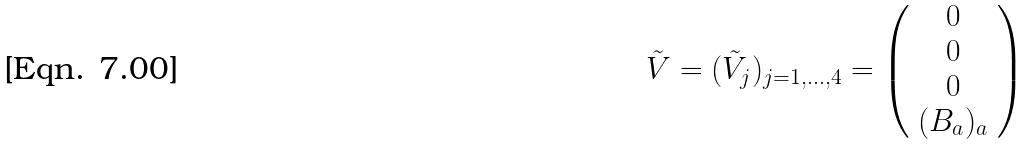Convert formula to latex. <formula><loc_0><loc_0><loc_500><loc_500>\tilde { V } = ( \tilde { V } _ { j } ) _ { j = 1 , \dots , 4 } = \left ( \begin{array} { c } 0 \\ 0 \\ 0 \\ ( { B } _ { a } ) _ { a } \end{array} \right )</formula> 